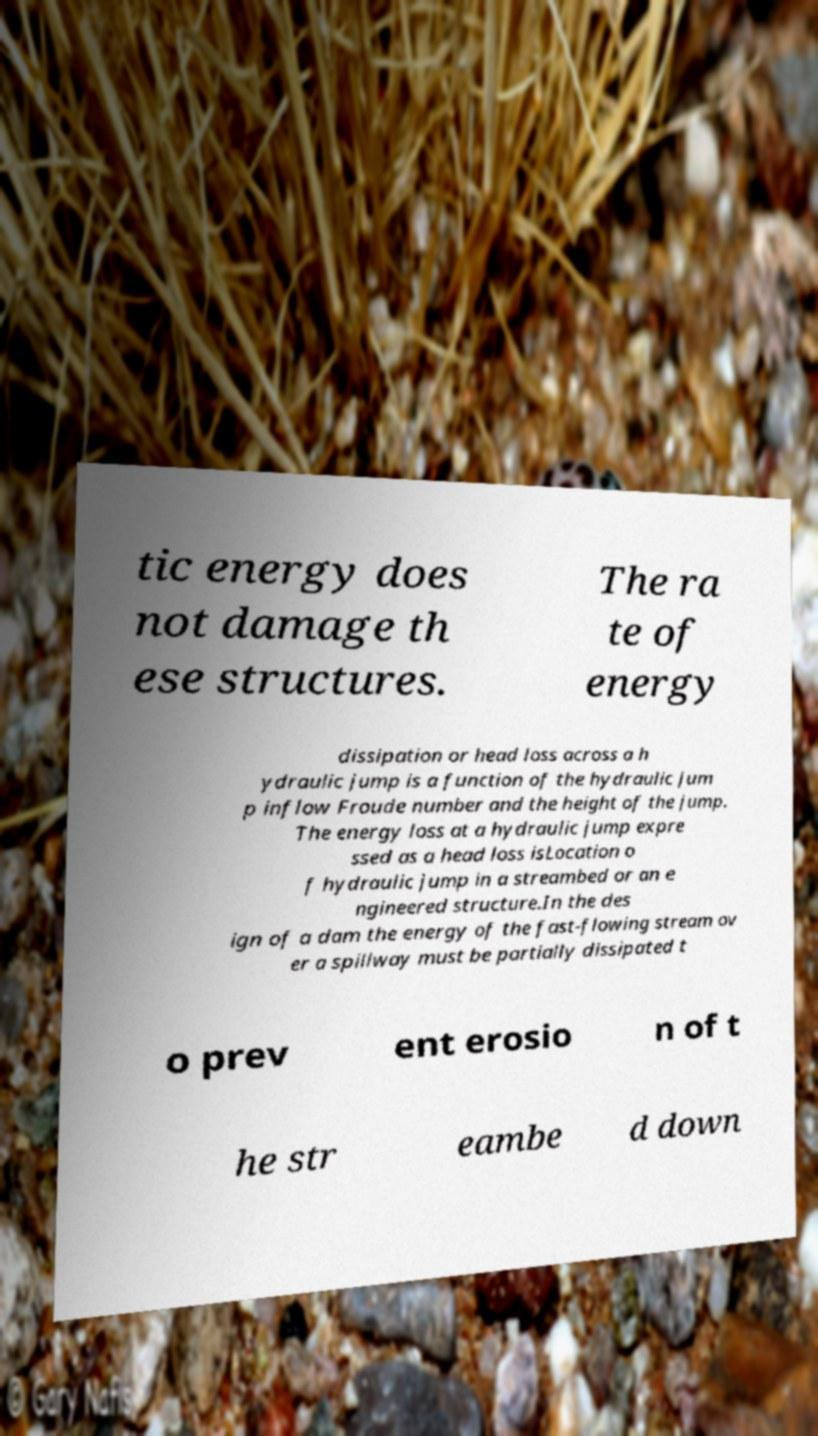Can you read and provide the text displayed in the image?This photo seems to have some interesting text. Can you extract and type it out for me? tic energy does not damage th ese structures. The ra te of energy dissipation or head loss across a h ydraulic jump is a function of the hydraulic jum p inflow Froude number and the height of the jump. The energy loss at a hydraulic jump expre ssed as a head loss isLocation o f hydraulic jump in a streambed or an e ngineered structure.In the des ign of a dam the energy of the fast-flowing stream ov er a spillway must be partially dissipated t o prev ent erosio n of t he str eambe d down 